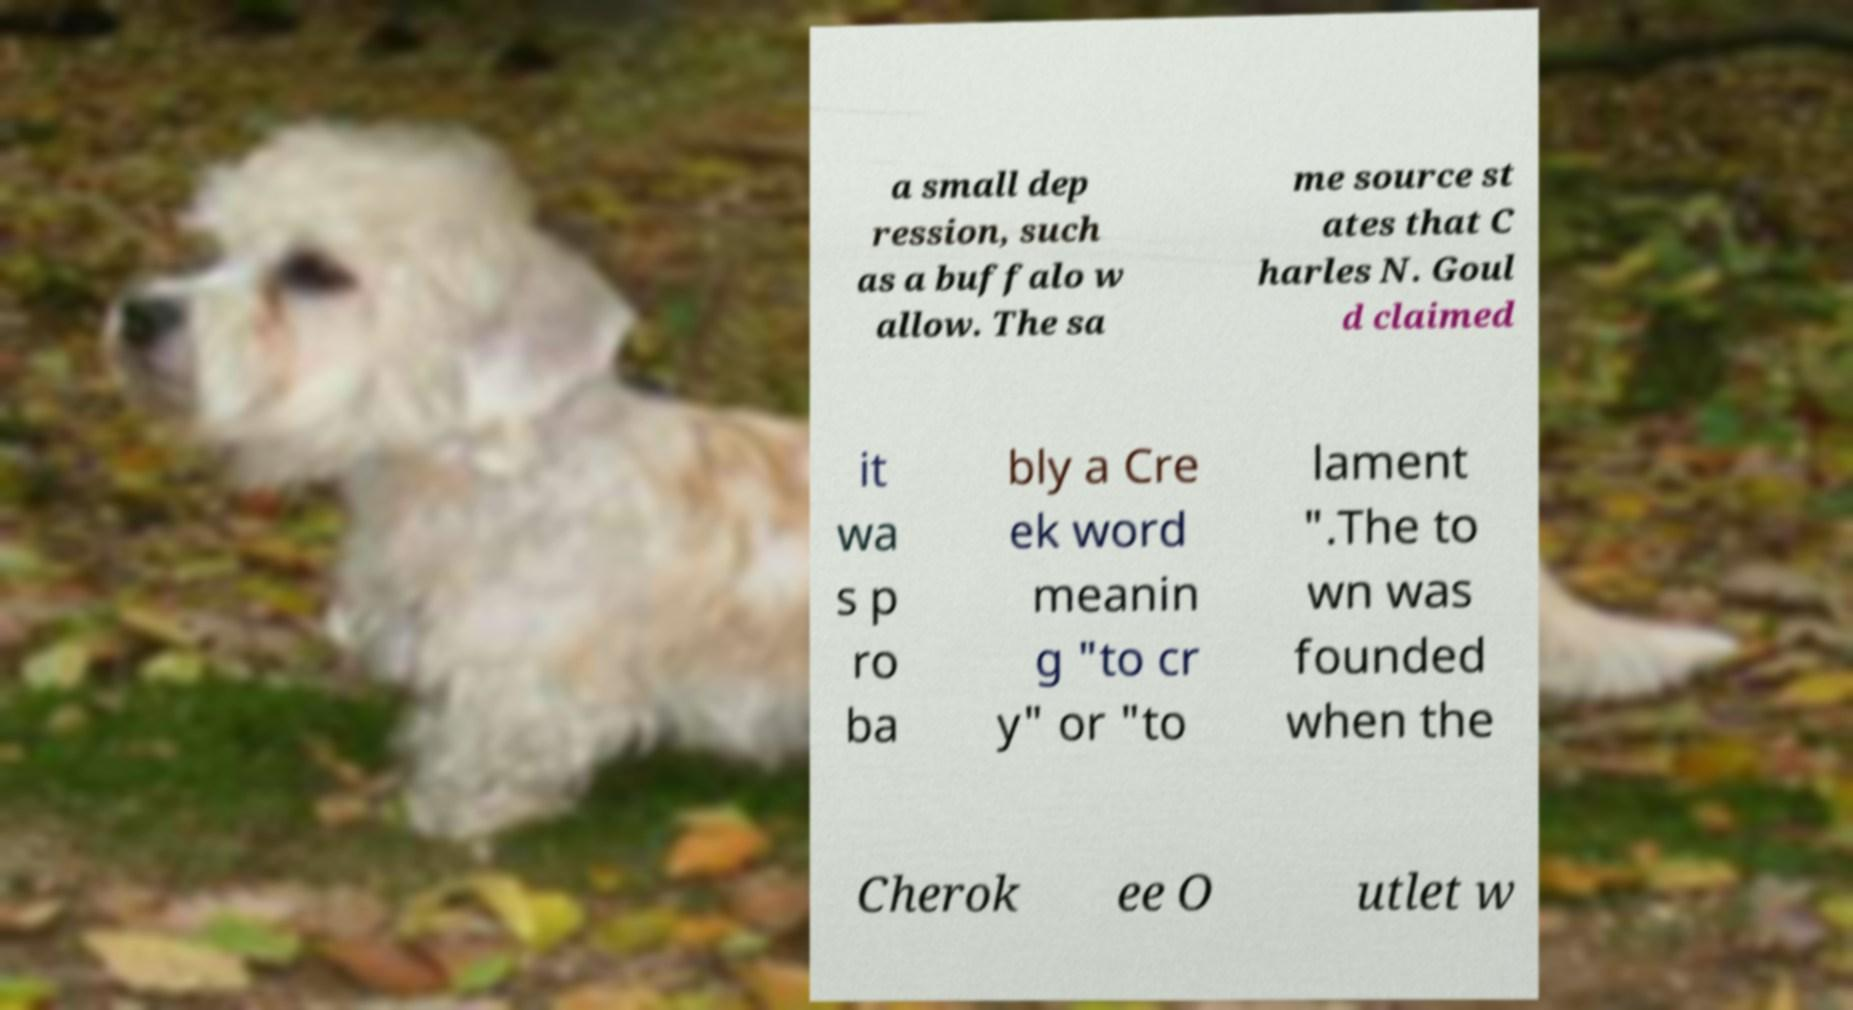What messages or text are displayed in this image? I need them in a readable, typed format. a small dep ression, such as a buffalo w allow. The sa me source st ates that C harles N. Goul d claimed it wa s p ro ba bly a Cre ek word meanin g "to cr y" or "to lament ".The to wn was founded when the Cherok ee O utlet w 